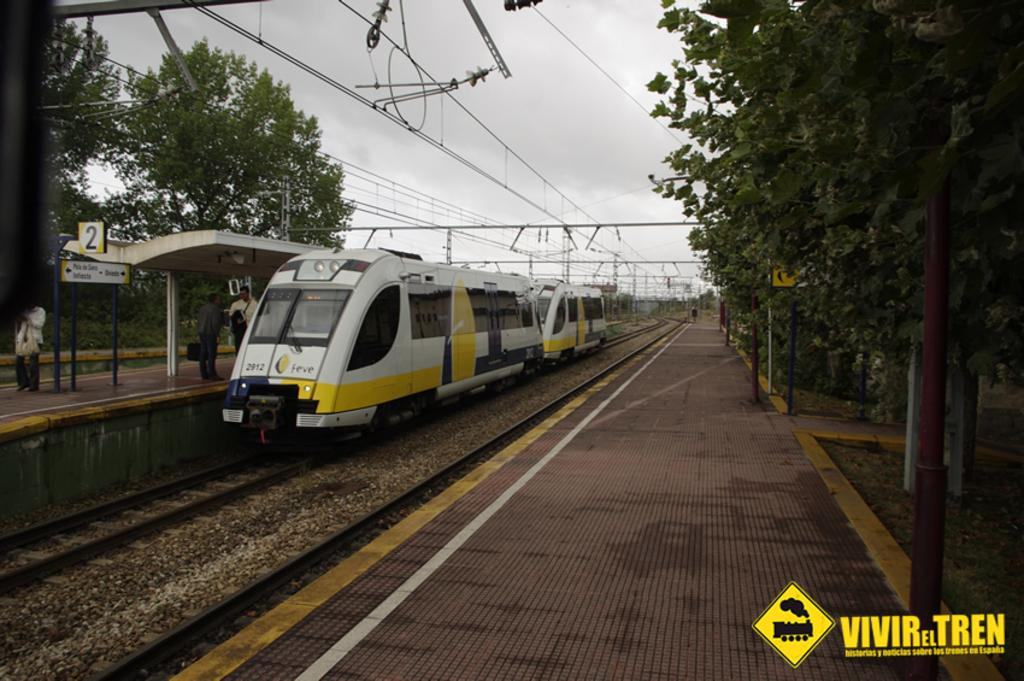<image>
Create a compact narrative representing the image presented. A blue, yellow and white train has 2912 under the front left window. 